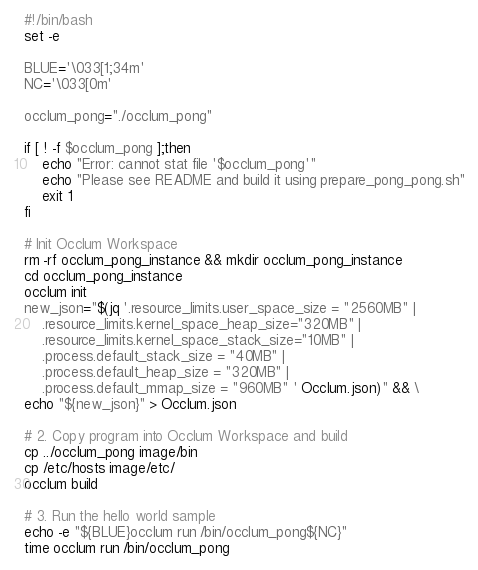<code> <loc_0><loc_0><loc_500><loc_500><_Bash_>#!/bin/bash
set -e

BLUE='\033[1;34m'
NC='\033[0m'

occlum_pong="./occlum_pong"

if [ ! -f $occlum_pong ];then
    echo "Error: cannot stat file '$occlum_pong'"
    echo "Please see README and build it using prepare_pong_pong.sh"
    exit 1
fi

# Init Occlum Workspace
rm -rf occlum_pong_instance && mkdir occlum_pong_instance
cd occlum_pong_instance
occlum init
new_json="$(jq '.resource_limits.user_space_size = "2560MB" |
	.resource_limits.kernel_space_heap_size="320MB" |
	.resource_limits.kernel_space_stack_size="10MB" |
	.process.default_stack_size = "40MB" |
	.process.default_heap_size = "320MB" |
	.process.default_mmap_size = "960MB" ' Occlum.json)" && \
echo "${new_json}" > Occlum.json

# 2. Copy program into Occlum Workspace and build
cp ../occlum_pong image/bin
cp /etc/hosts image/etc/
occlum build

# 3. Run the hello world sample
echo -e "${BLUE}occlum run /bin/occlum_pong${NC}"
time occlum run /bin/occlum_pong
</code> 